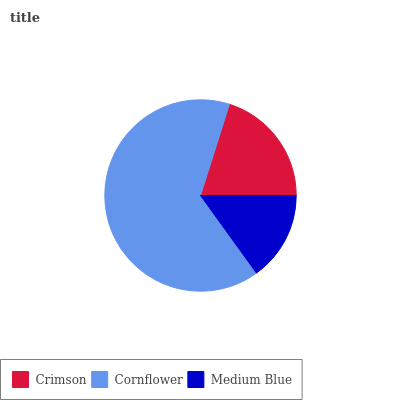Is Medium Blue the minimum?
Answer yes or no. Yes. Is Cornflower the maximum?
Answer yes or no. Yes. Is Cornflower the minimum?
Answer yes or no. No. Is Medium Blue the maximum?
Answer yes or no. No. Is Cornflower greater than Medium Blue?
Answer yes or no. Yes. Is Medium Blue less than Cornflower?
Answer yes or no. Yes. Is Medium Blue greater than Cornflower?
Answer yes or no. No. Is Cornflower less than Medium Blue?
Answer yes or no. No. Is Crimson the high median?
Answer yes or no. Yes. Is Crimson the low median?
Answer yes or no. Yes. Is Medium Blue the high median?
Answer yes or no. No. Is Cornflower the low median?
Answer yes or no. No. 